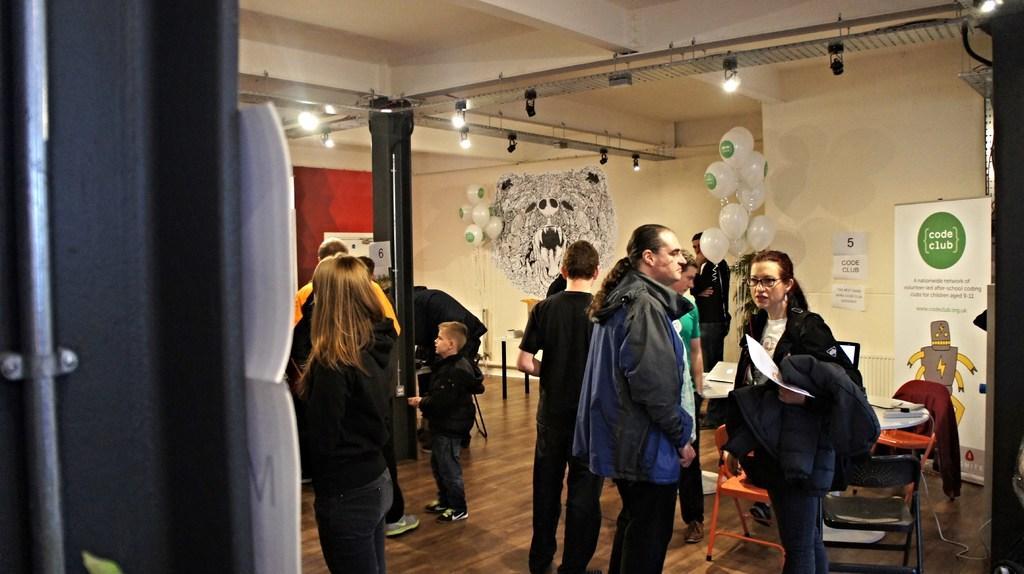Describe this image in one or two sentences. In this image, we can see many people and some are wearing coats and holding some objects in their hands. In the background, there are chairs and some objects on the table and we can see a board and posters on the wall and there are balloons, lights, a pole and some stands. At the top, there is a roof and at the bottom, there is a floor. 